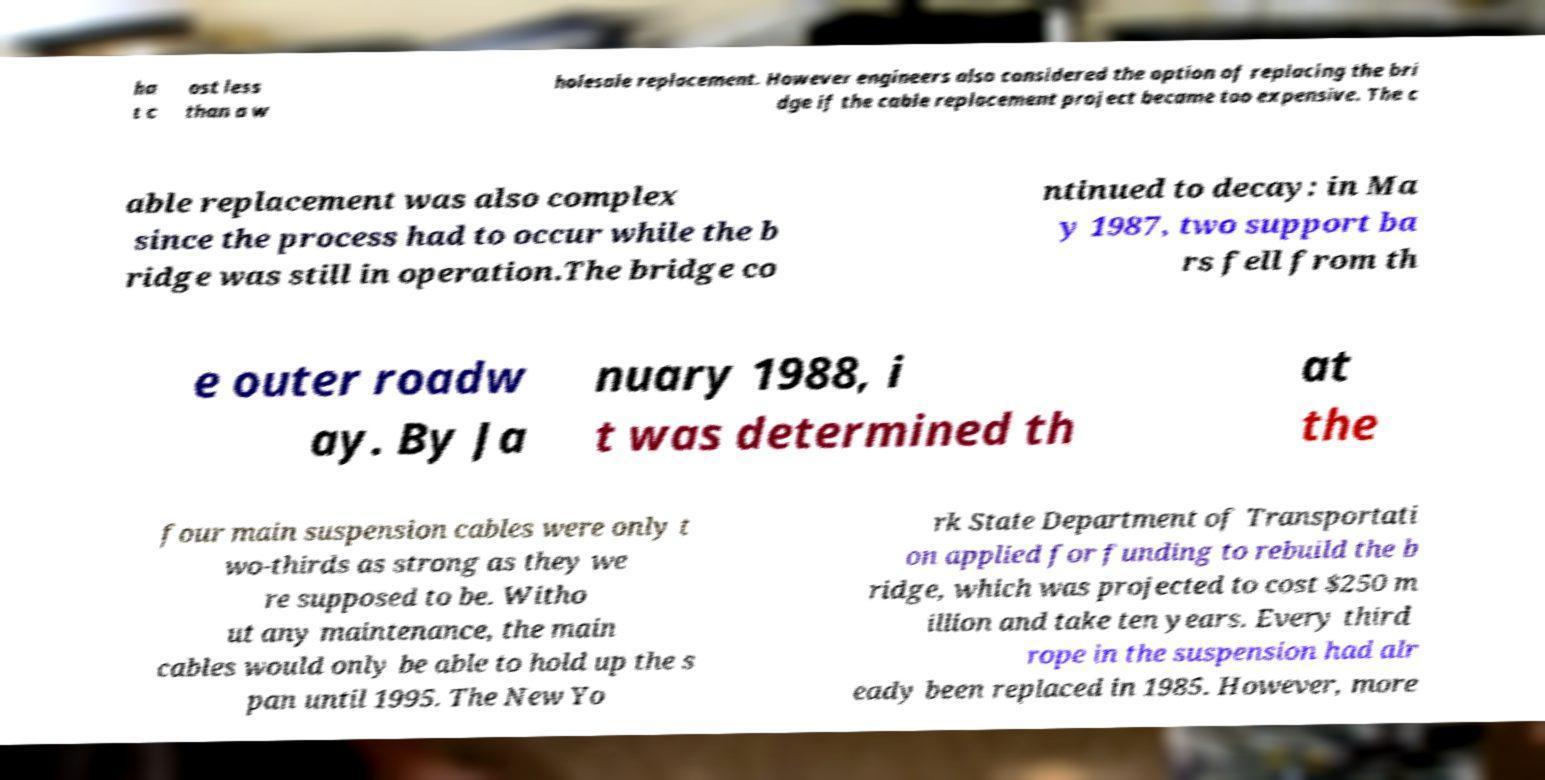Please identify and transcribe the text found in this image. ha t c ost less than a w holesale replacement. However engineers also considered the option of replacing the bri dge if the cable replacement project became too expensive. The c able replacement was also complex since the process had to occur while the b ridge was still in operation.The bridge co ntinued to decay: in Ma y 1987, two support ba rs fell from th e outer roadw ay. By Ja nuary 1988, i t was determined th at the four main suspension cables were only t wo-thirds as strong as they we re supposed to be. Witho ut any maintenance, the main cables would only be able to hold up the s pan until 1995. The New Yo rk State Department of Transportati on applied for funding to rebuild the b ridge, which was projected to cost $250 m illion and take ten years. Every third rope in the suspension had alr eady been replaced in 1985. However, more 